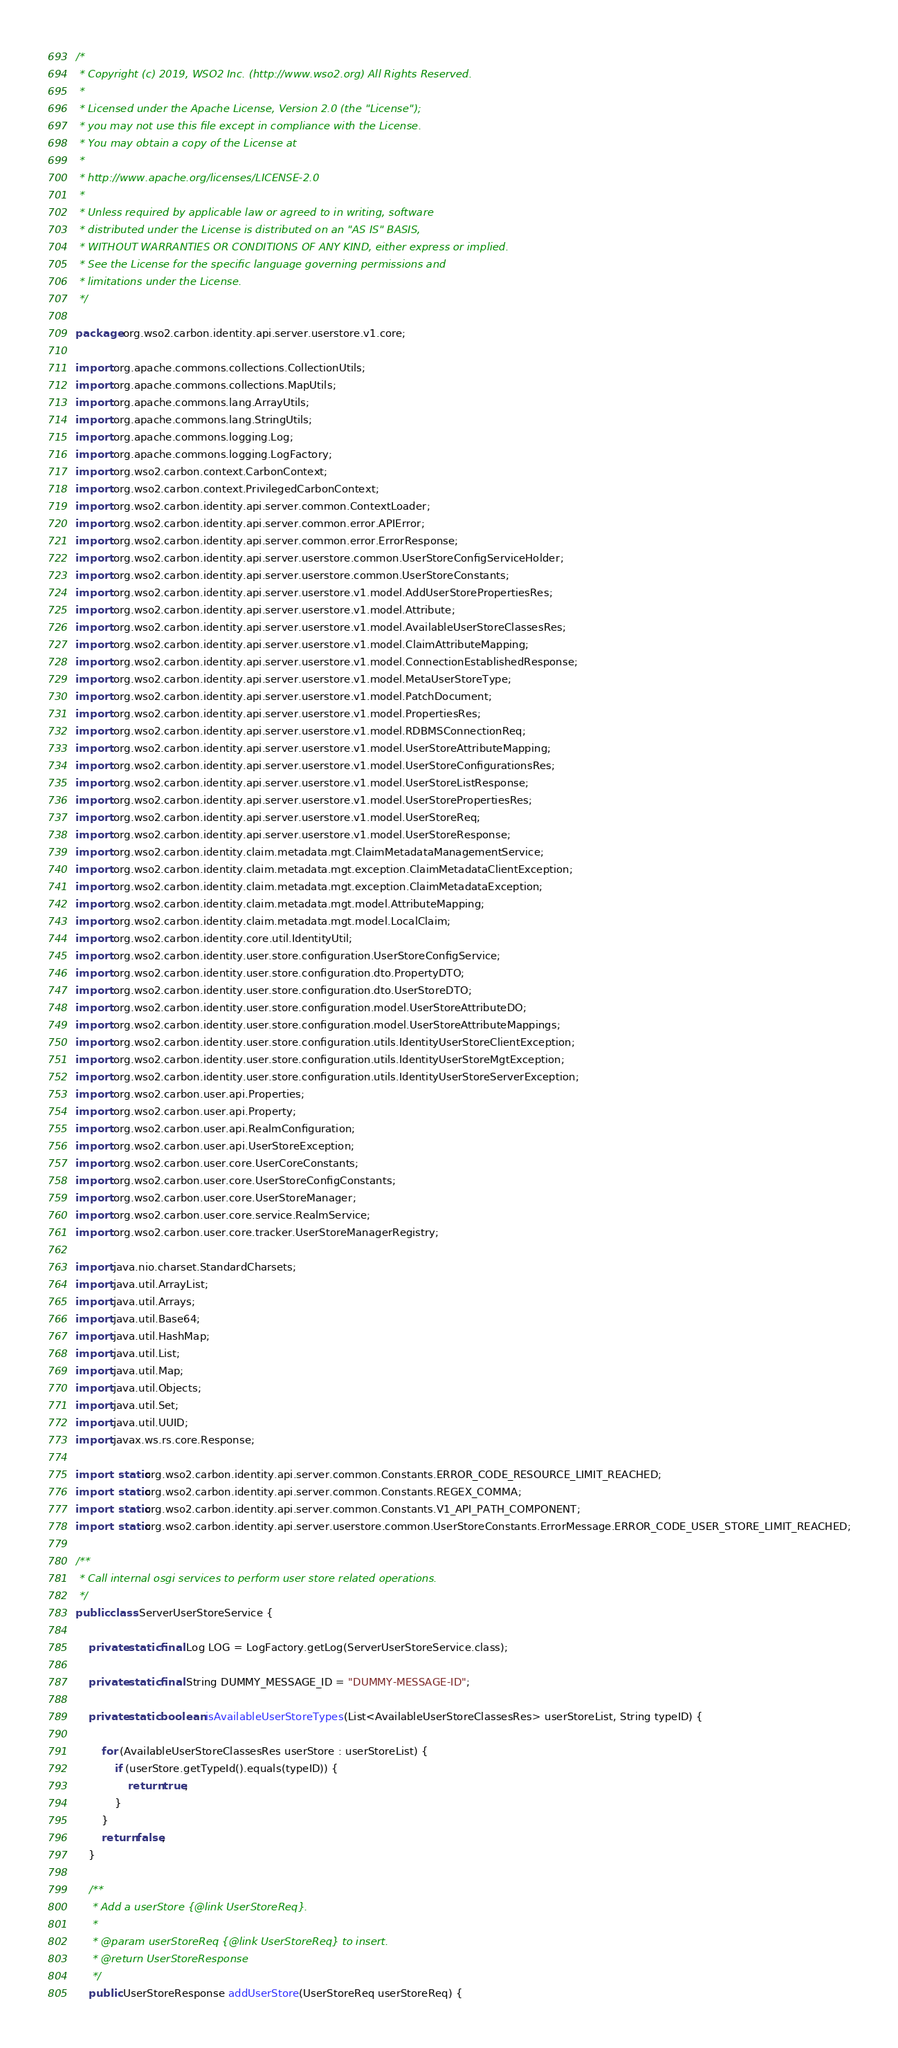Convert code to text. <code><loc_0><loc_0><loc_500><loc_500><_Java_>/*
 * Copyright (c) 2019, WSO2 Inc. (http://www.wso2.org) All Rights Reserved.
 *
 * Licensed under the Apache License, Version 2.0 (the "License");
 * you may not use this file except in compliance with the License.
 * You may obtain a copy of the License at
 *
 * http://www.apache.org/licenses/LICENSE-2.0
 *
 * Unless required by applicable law or agreed to in writing, software
 * distributed under the License is distributed on an "AS IS" BASIS,
 * WITHOUT WARRANTIES OR CONDITIONS OF ANY KIND, either express or implied.
 * See the License for the specific language governing permissions and
 * limitations under the License.
 */

package org.wso2.carbon.identity.api.server.userstore.v1.core;

import org.apache.commons.collections.CollectionUtils;
import org.apache.commons.collections.MapUtils;
import org.apache.commons.lang.ArrayUtils;
import org.apache.commons.lang.StringUtils;
import org.apache.commons.logging.Log;
import org.apache.commons.logging.LogFactory;
import org.wso2.carbon.context.CarbonContext;
import org.wso2.carbon.context.PrivilegedCarbonContext;
import org.wso2.carbon.identity.api.server.common.ContextLoader;
import org.wso2.carbon.identity.api.server.common.error.APIError;
import org.wso2.carbon.identity.api.server.common.error.ErrorResponse;
import org.wso2.carbon.identity.api.server.userstore.common.UserStoreConfigServiceHolder;
import org.wso2.carbon.identity.api.server.userstore.common.UserStoreConstants;
import org.wso2.carbon.identity.api.server.userstore.v1.model.AddUserStorePropertiesRes;
import org.wso2.carbon.identity.api.server.userstore.v1.model.Attribute;
import org.wso2.carbon.identity.api.server.userstore.v1.model.AvailableUserStoreClassesRes;
import org.wso2.carbon.identity.api.server.userstore.v1.model.ClaimAttributeMapping;
import org.wso2.carbon.identity.api.server.userstore.v1.model.ConnectionEstablishedResponse;
import org.wso2.carbon.identity.api.server.userstore.v1.model.MetaUserStoreType;
import org.wso2.carbon.identity.api.server.userstore.v1.model.PatchDocument;
import org.wso2.carbon.identity.api.server.userstore.v1.model.PropertiesRes;
import org.wso2.carbon.identity.api.server.userstore.v1.model.RDBMSConnectionReq;
import org.wso2.carbon.identity.api.server.userstore.v1.model.UserStoreAttributeMapping;
import org.wso2.carbon.identity.api.server.userstore.v1.model.UserStoreConfigurationsRes;
import org.wso2.carbon.identity.api.server.userstore.v1.model.UserStoreListResponse;
import org.wso2.carbon.identity.api.server.userstore.v1.model.UserStorePropertiesRes;
import org.wso2.carbon.identity.api.server.userstore.v1.model.UserStoreReq;
import org.wso2.carbon.identity.api.server.userstore.v1.model.UserStoreResponse;
import org.wso2.carbon.identity.claim.metadata.mgt.ClaimMetadataManagementService;
import org.wso2.carbon.identity.claim.metadata.mgt.exception.ClaimMetadataClientException;
import org.wso2.carbon.identity.claim.metadata.mgt.exception.ClaimMetadataException;
import org.wso2.carbon.identity.claim.metadata.mgt.model.AttributeMapping;
import org.wso2.carbon.identity.claim.metadata.mgt.model.LocalClaim;
import org.wso2.carbon.identity.core.util.IdentityUtil;
import org.wso2.carbon.identity.user.store.configuration.UserStoreConfigService;
import org.wso2.carbon.identity.user.store.configuration.dto.PropertyDTO;
import org.wso2.carbon.identity.user.store.configuration.dto.UserStoreDTO;
import org.wso2.carbon.identity.user.store.configuration.model.UserStoreAttributeDO;
import org.wso2.carbon.identity.user.store.configuration.model.UserStoreAttributeMappings;
import org.wso2.carbon.identity.user.store.configuration.utils.IdentityUserStoreClientException;
import org.wso2.carbon.identity.user.store.configuration.utils.IdentityUserStoreMgtException;
import org.wso2.carbon.identity.user.store.configuration.utils.IdentityUserStoreServerException;
import org.wso2.carbon.user.api.Properties;
import org.wso2.carbon.user.api.Property;
import org.wso2.carbon.user.api.RealmConfiguration;
import org.wso2.carbon.user.api.UserStoreException;
import org.wso2.carbon.user.core.UserCoreConstants;
import org.wso2.carbon.user.core.UserStoreConfigConstants;
import org.wso2.carbon.user.core.UserStoreManager;
import org.wso2.carbon.user.core.service.RealmService;
import org.wso2.carbon.user.core.tracker.UserStoreManagerRegistry;

import java.nio.charset.StandardCharsets;
import java.util.ArrayList;
import java.util.Arrays;
import java.util.Base64;
import java.util.HashMap;
import java.util.List;
import java.util.Map;
import java.util.Objects;
import java.util.Set;
import java.util.UUID;
import javax.ws.rs.core.Response;

import static org.wso2.carbon.identity.api.server.common.Constants.ERROR_CODE_RESOURCE_LIMIT_REACHED;
import static org.wso2.carbon.identity.api.server.common.Constants.REGEX_COMMA;
import static org.wso2.carbon.identity.api.server.common.Constants.V1_API_PATH_COMPONENT;
import static org.wso2.carbon.identity.api.server.userstore.common.UserStoreConstants.ErrorMessage.ERROR_CODE_USER_STORE_LIMIT_REACHED;

/**
 * Call internal osgi services to perform user store related operations.
 */
public class ServerUserStoreService {

    private static final Log LOG = LogFactory.getLog(ServerUserStoreService.class);

    private static final String DUMMY_MESSAGE_ID = "DUMMY-MESSAGE-ID";

    private static boolean isAvailableUserStoreTypes(List<AvailableUserStoreClassesRes> userStoreList, String typeID) {

        for (AvailableUserStoreClassesRes userStore : userStoreList) {
            if (userStore.getTypeId().equals(typeID)) {
                return true;
            }
        }
        return false;
    }

    /**
     * Add a userStore {@link UserStoreReq}.
     *
     * @param userStoreReq {@link UserStoreReq} to insert.
     * @return UserStoreResponse
     */
    public UserStoreResponse addUserStore(UserStoreReq userStoreReq) {
</code> 